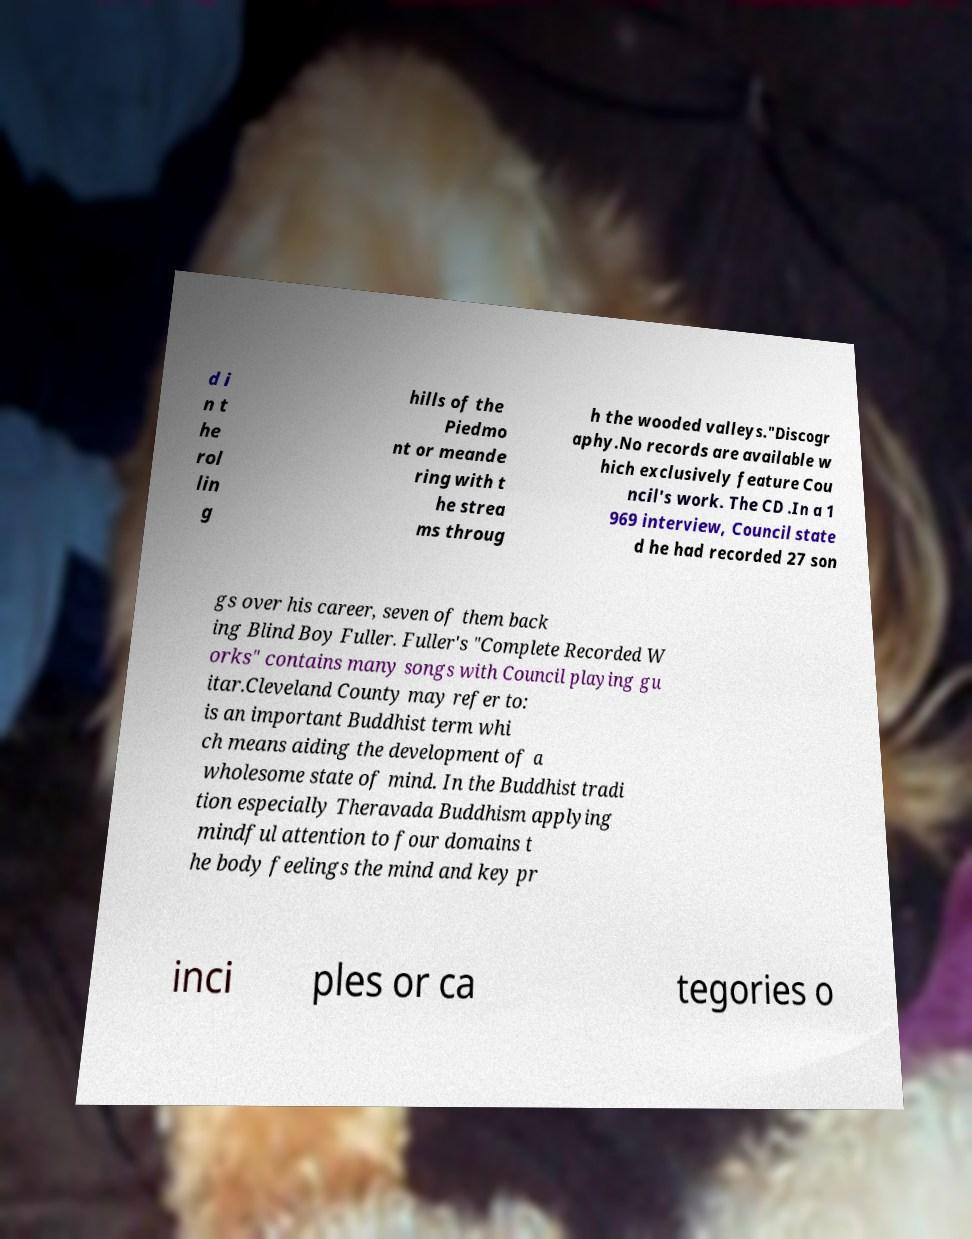For documentation purposes, I need the text within this image transcribed. Could you provide that? d i n t he rol lin g hills of the Piedmo nt or meande ring with t he strea ms throug h the wooded valleys."Discogr aphy.No records are available w hich exclusively feature Cou ncil's work. The CD .In a 1 969 interview, Council state d he had recorded 27 son gs over his career, seven of them back ing Blind Boy Fuller. Fuller's "Complete Recorded W orks" contains many songs with Council playing gu itar.Cleveland County may refer to: is an important Buddhist term whi ch means aiding the development of a wholesome state of mind. In the Buddhist tradi tion especially Theravada Buddhism applying mindful attention to four domains t he body feelings the mind and key pr inci ples or ca tegories o 